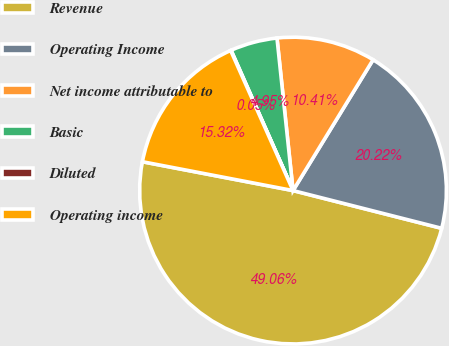Convert chart. <chart><loc_0><loc_0><loc_500><loc_500><pie_chart><fcel>Revenue<fcel>Operating Income<fcel>Net income attributable to<fcel>Basic<fcel>Diluted<fcel>Operating income<nl><fcel>49.06%<fcel>20.22%<fcel>10.41%<fcel>4.95%<fcel>0.05%<fcel>15.32%<nl></chart> 